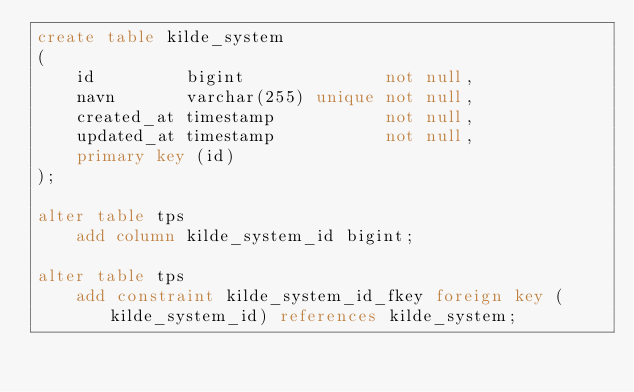<code> <loc_0><loc_0><loc_500><loc_500><_SQL_>create table kilde_system
(
    id         bigint              not null,
    navn       varchar(255) unique not null,
    created_at timestamp           not null,
    updated_at timestamp           not null,
    primary key (id)
);

alter table tps
    add column kilde_system_id bigint;

alter table tps
    add constraint kilde_system_id_fkey foreign key (kilde_system_id) references kilde_system;</code> 